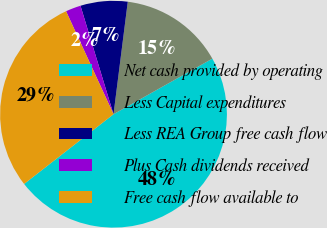<chart> <loc_0><loc_0><loc_500><loc_500><pie_chart><fcel>Net cash provided by operating<fcel>Less Capital expenditures<fcel>Less REA Group free cash flow<fcel>Plus Cash dividends received<fcel>Free cash flow available to<nl><fcel>47.61%<fcel>14.84%<fcel>6.71%<fcel>2.17%<fcel>28.67%<nl></chart> 